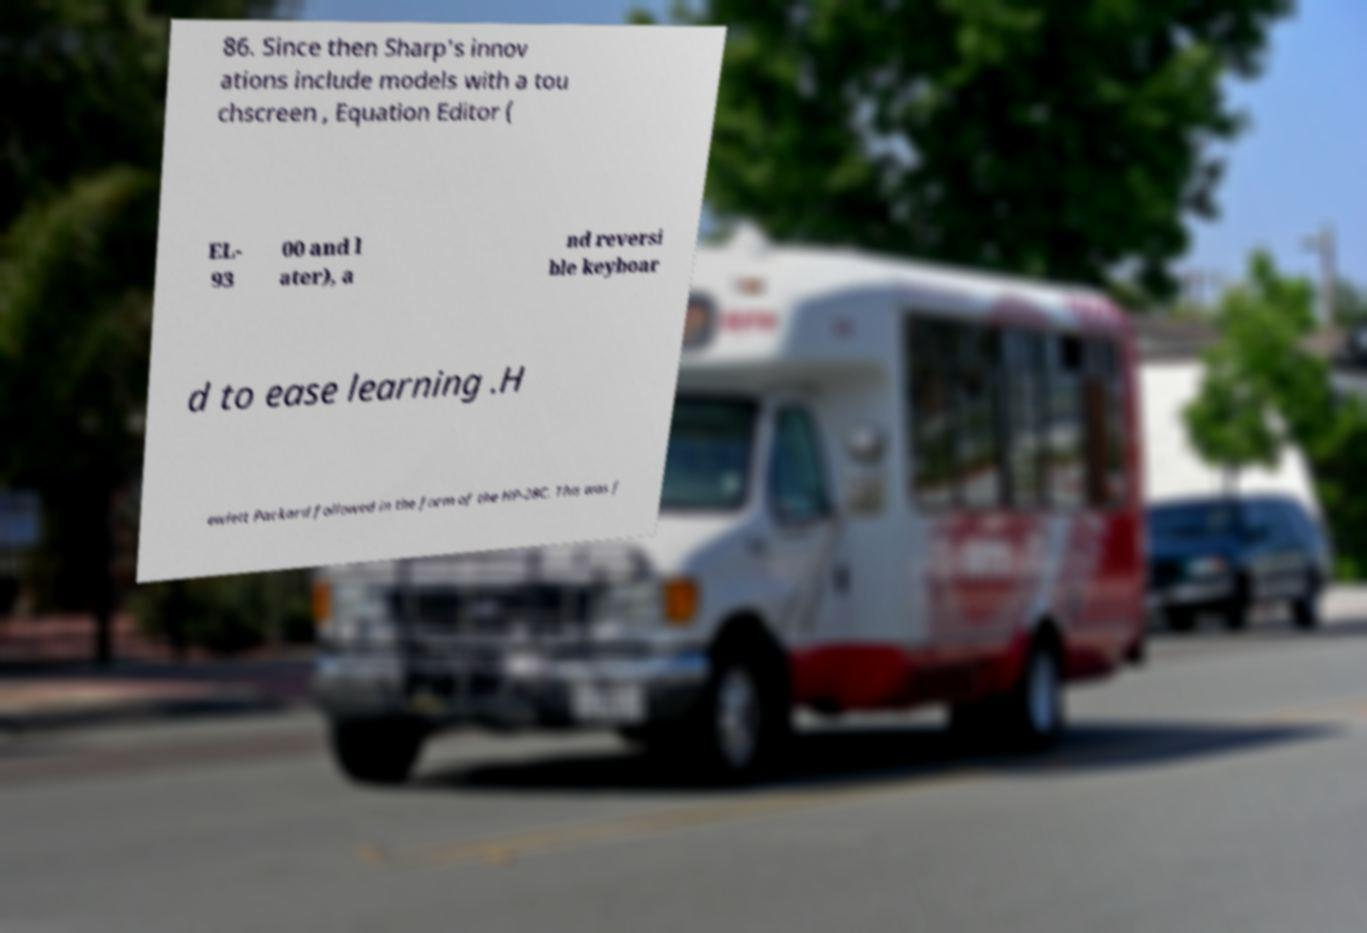I need the written content from this picture converted into text. Can you do that? 86. Since then Sharp's innov ations include models with a tou chscreen , Equation Editor ( EL- 93 00 and l ater), a nd reversi ble keyboar d to ease learning .H ewlett Packard followed in the form of the HP-28C. This was f 